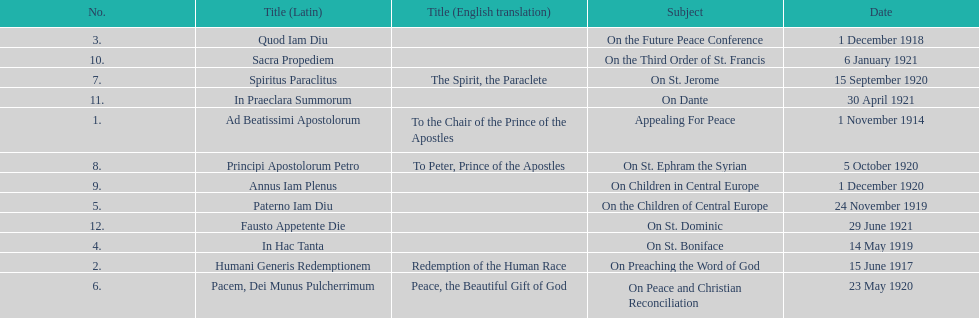What is the total number of encyclicals to take place in december? 2. 